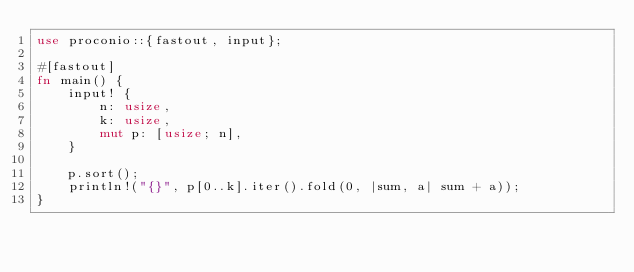Convert code to text. <code><loc_0><loc_0><loc_500><loc_500><_Rust_>use proconio::{fastout, input};

#[fastout]
fn main() {
    input! {
        n: usize,
        k: usize,
        mut p: [usize; n],
    }

    p.sort();
    println!("{}", p[0..k].iter().fold(0, |sum, a| sum + a));
}
</code> 